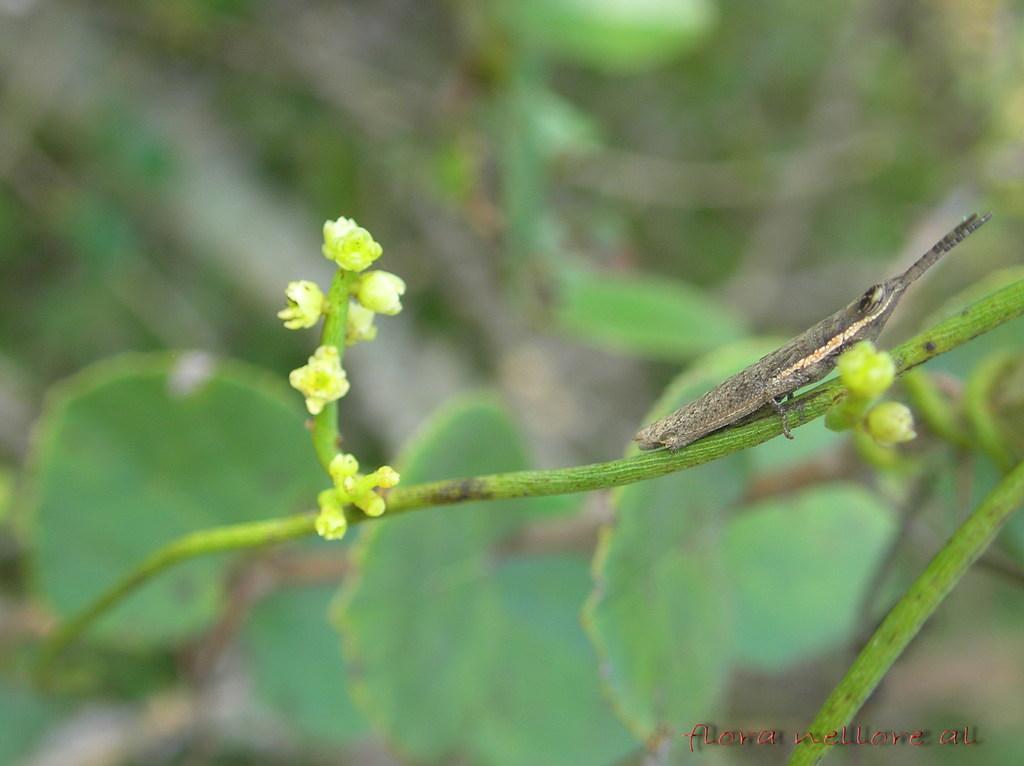Can you describe this image briefly? In the center of the image we can see insect on the plant. 